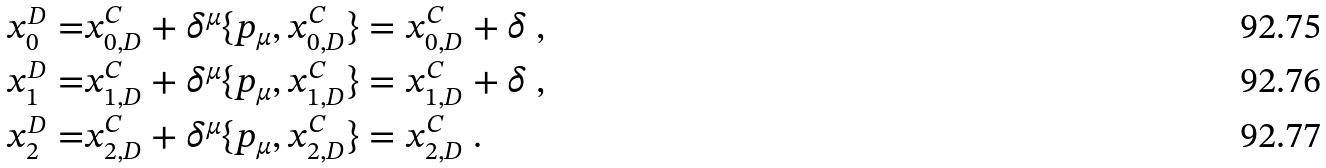Convert formula to latex. <formula><loc_0><loc_0><loc_500><loc_500>x _ { 0 } ^ { D } = & x _ { 0 , D } ^ { C } + \delta ^ { \mu } \{ p _ { \mu } , x _ { 0 , D } ^ { C } \} = x _ { 0 , D } ^ { C } + \delta \ , \\ x _ { 1 } ^ { D } = & x _ { 1 , D } ^ { C } + \delta ^ { \mu } \{ p _ { \mu } , x _ { 1 , D } ^ { C } \} = x _ { 1 , D } ^ { C } + \delta \ , \\ x _ { 2 } ^ { D } = & x _ { 2 , D } ^ { C } + \delta ^ { \mu } \{ p _ { \mu } , x _ { 2 , D } ^ { C } \} = x _ { 2 , D } ^ { C } \ .</formula> 